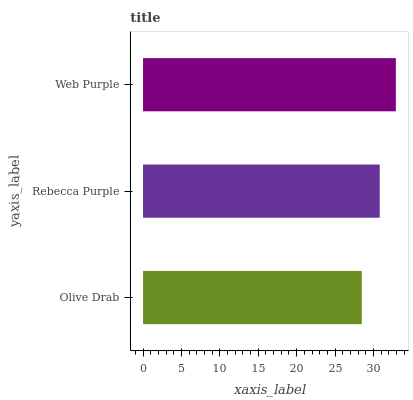Is Olive Drab the minimum?
Answer yes or no. Yes. Is Web Purple the maximum?
Answer yes or no. Yes. Is Rebecca Purple the minimum?
Answer yes or no. No. Is Rebecca Purple the maximum?
Answer yes or no. No. Is Rebecca Purple greater than Olive Drab?
Answer yes or no. Yes. Is Olive Drab less than Rebecca Purple?
Answer yes or no. Yes. Is Olive Drab greater than Rebecca Purple?
Answer yes or no. No. Is Rebecca Purple less than Olive Drab?
Answer yes or no. No. Is Rebecca Purple the high median?
Answer yes or no. Yes. Is Rebecca Purple the low median?
Answer yes or no. Yes. Is Olive Drab the high median?
Answer yes or no. No. Is Web Purple the low median?
Answer yes or no. No. 